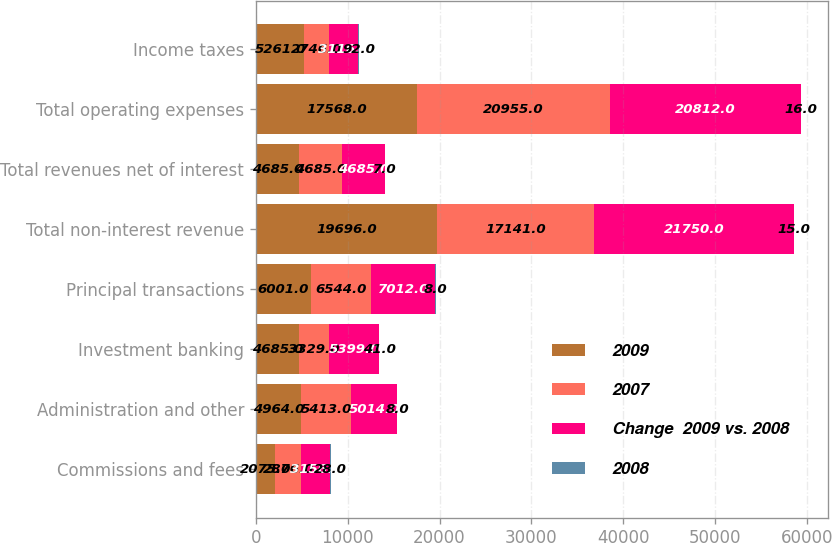<chart> <loc_0><loc_0><loc_500><loc_500><stacked_bar_chart><ecel><fcel>Commissions and fees<fcel>Administration and other<fcel>Investment banking<fcel>Principal transactions<fcel>Total non-interest revenue<fcel>Total revenues net of interest<fcel>Total operating expenses<fcel>Income taxes<nl><fcel>2009<fcel>2075<fcel>4964<fcel>4685<fcel>6001<fcel>19696<fcel>4685<fcel>17568<fcel>5261<nl><fcel>2007<fcel>2876<fcel>5413<fcel>3329<fcel>6544<fcel>17141<fcel>4685<fcel>20955<fcel>2746<nl><fcel>Change  2009 vs. 2008<fcel>3156<fcel>5014<fcel>5399<fcel>7012<fcel>21750<fcel>4685<fcel>20812<fcel>3116<nl><fcel>2008<fcel>28<fcel>8<fcel>41<fcel>8<fcel>15<fcel>7<fcel>16<fcel>92<nl></chart> 